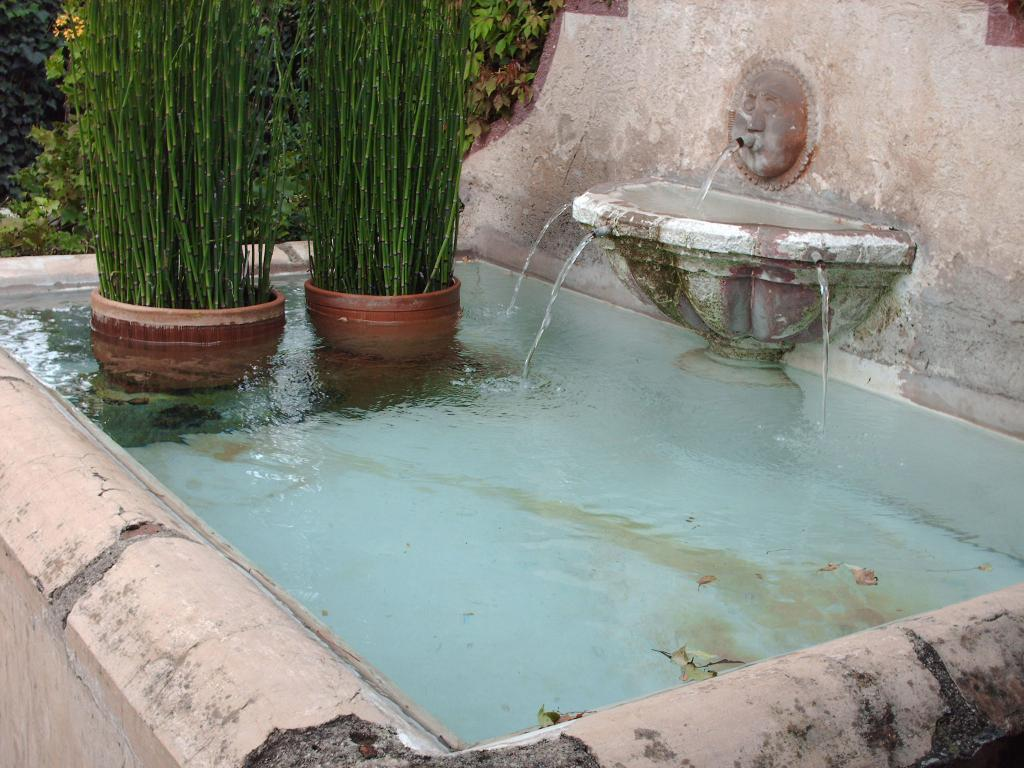What is the main feature in the center of the image? There is water in the center of the image. What other elements can be seen in the image? There are plants and a water fountain on the right side of the image. What can be seen in the background of the image? There are trees in the background of the image. What type of cherry is growing on the trees in the image? There are no cherries or trees with cherries present in the image. How does the water fountain affect the mind of the person in the image? There is no person present in the image, so it is impossible to determine the effect of the water fountain on their mind. 